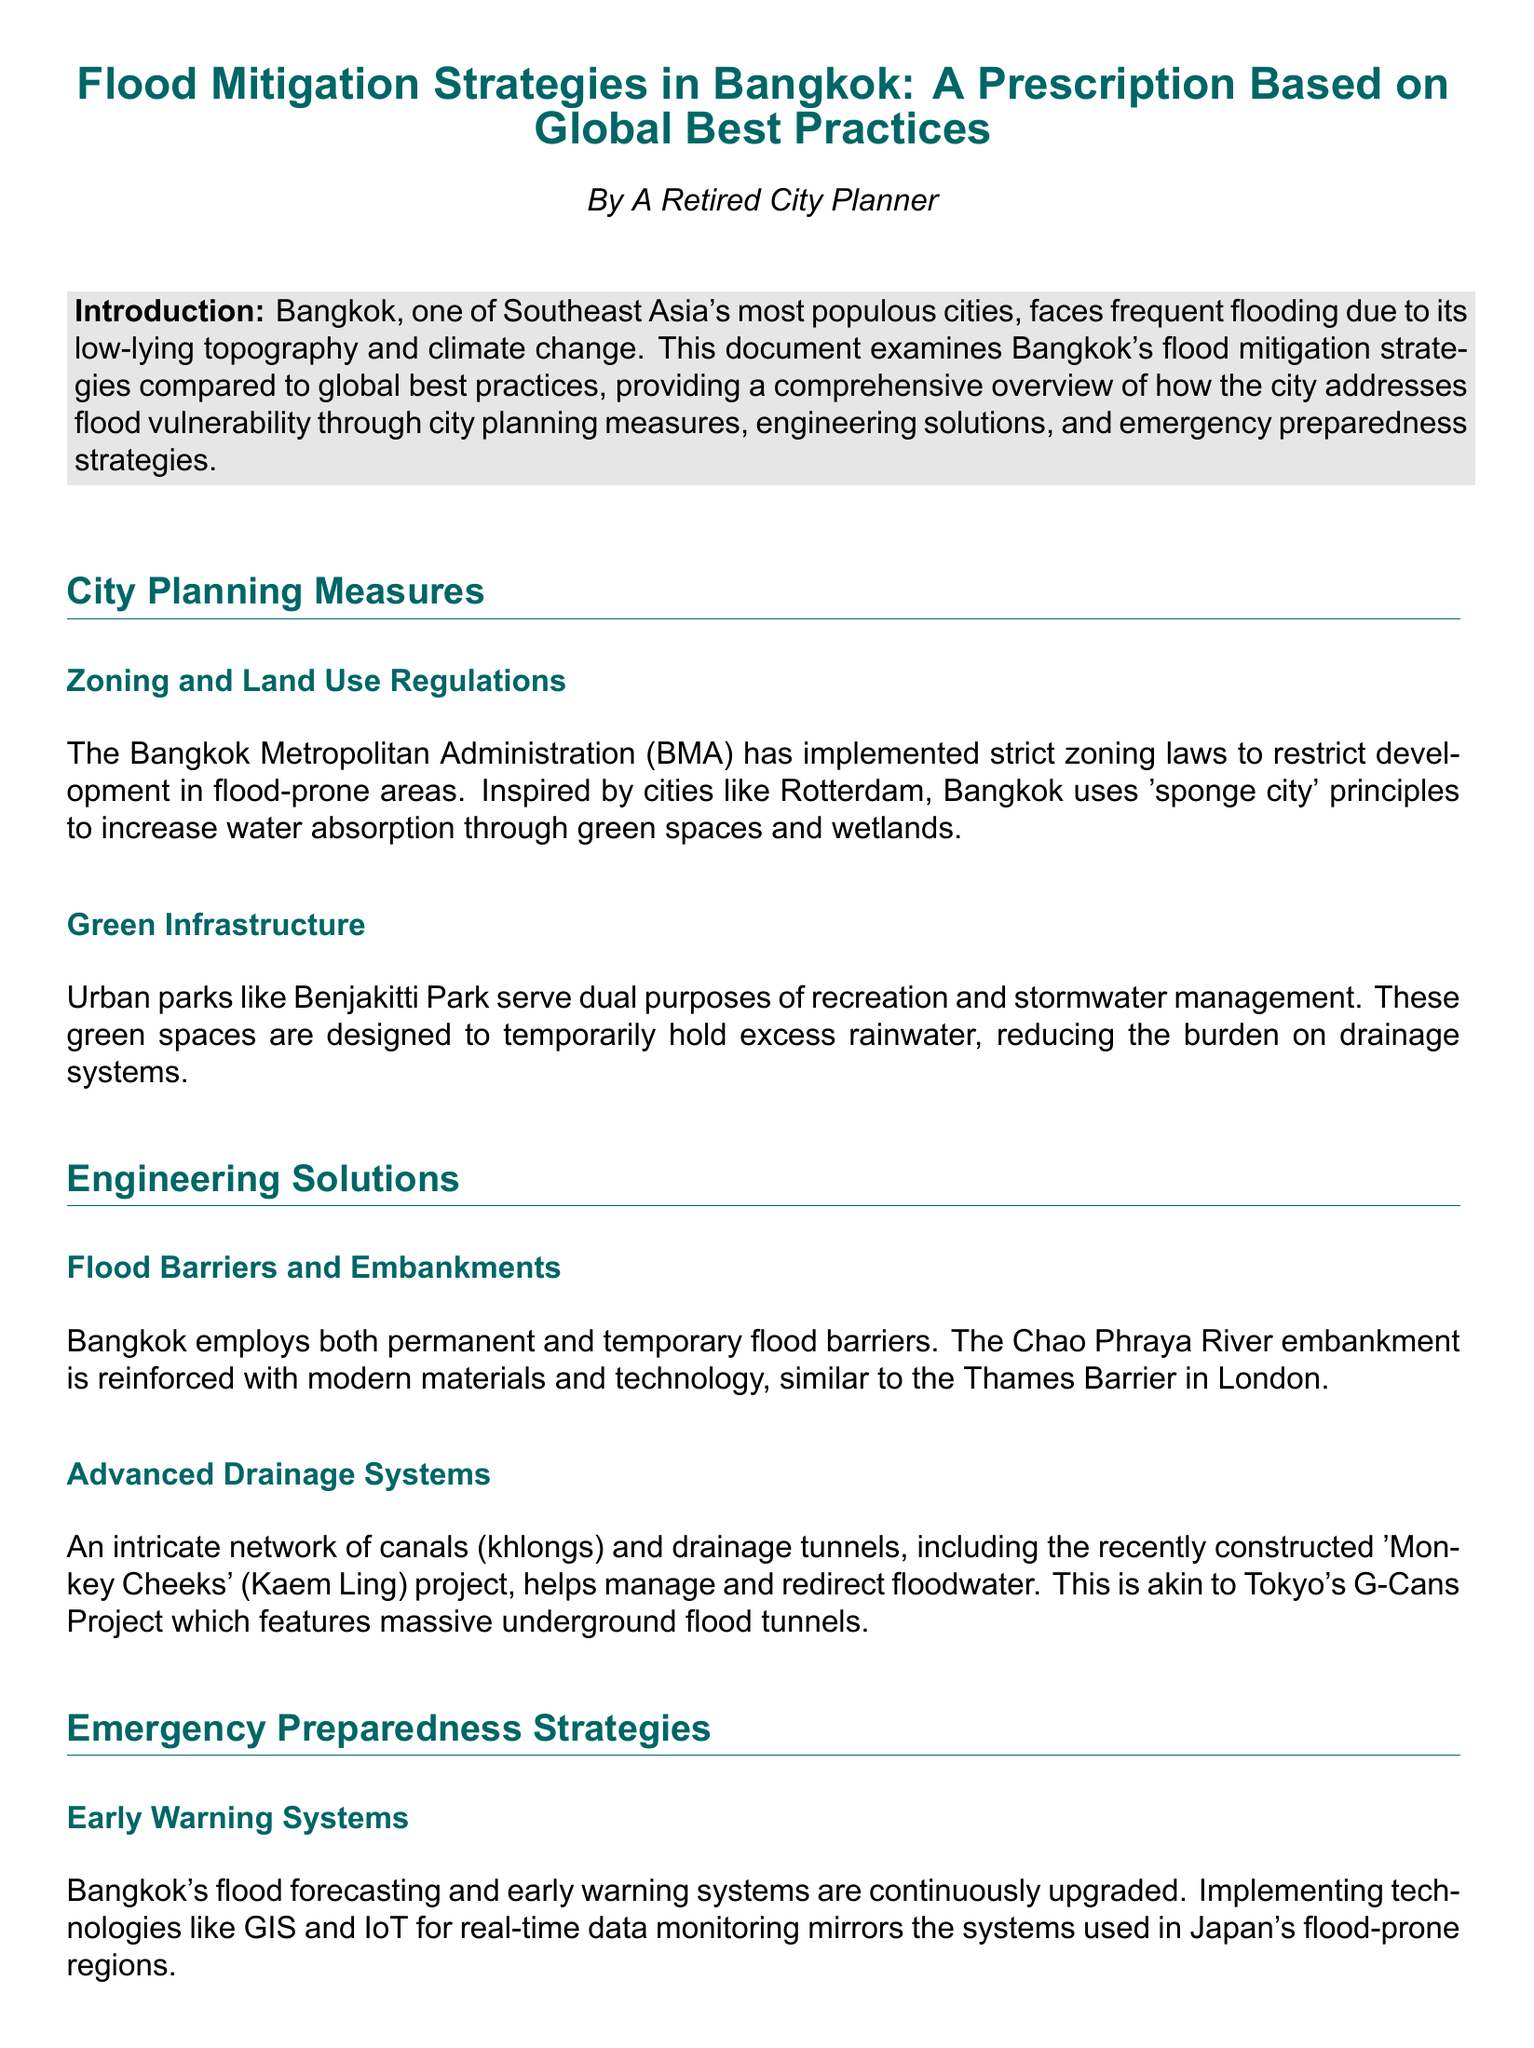What is the primary cause of flooding in Bangkok? The document highlights that Bangkok experiences flooding due to its low-lying topography and climate change.
Answer: low-lying topography and climate change Which city's practices inspired Bangkok's sponge city principles? The document mentions that Rotterdam's practices inspired Bangkok's sponge city principles.
Answer: Rotterdam What name is given to the recently constructed flood management project in Bangkok? The document refers to the new flood management project as the 'Monkey Cheeks' project.
Answer: Monkey Cheeks What type of systems does Bangkok utilize for early flood warning? The document states that Bangkok uses flood forecasting and early warning systems that incorporate technologies like GIS and IoT.
Answer: GIS and IoT How often are community drills conducted in Bangkok? The document implies that public awareness campaigns and community drills are conducted regularly to prepare residents for floods.
Answer: regularly What engineering solution is compared to the Thames Barrier in London? The document compares Bangkok's flood barriers and embankments to the Thames Barrier in London.
Answer: Thames Barrier What is the purpose of Benjakitti Park in Bangkok? The document indicates that Benjakitti Park serves the dual purposes of recreation and stormwater management.
Answer: recreation and stormwater management In which city is the Ready NY program implemented? The document states that the Ready NY program is implemented in New York City.
Answer: New York City 